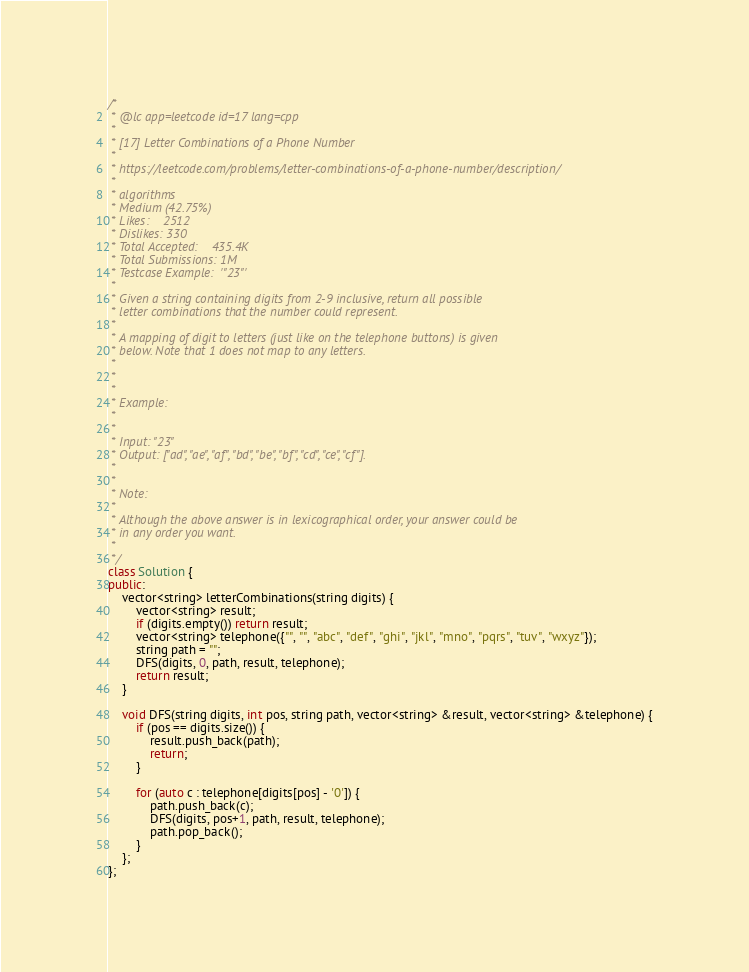<code> <loc_0><loc_0><loc_500><loc_500><_C++_>/*
 * @lc app=leetcode id=17 lang=cpp
 *
 * [17] Letter Combinations of a Phone Number
 *
 * https://leetcode.com/problems/letter-combinations-of-a-phone-number/description/
 *
 * algorithms
 * Medium (42.75%)
 * Likes:    2512
 * Dislikes: 330
 * Total Accepted:    435.4K
 * Total Submissions: 1M
 * Testcase Example:  '"23"'
 *
 * Given a string containing digits from 2-9 inclusive, return all possible
 * letter combinations that the number could represent.
 * 
 * A mapping of digit to letters (just like on the telephone buttons) is given
 * below. Note that 1 does not map to any letters.
 * 
 * 
 * 
 * Example:
 * 
 * 
 * Input: "23"
 * Output: ["ad", "ae", "af", "bd", "be", "bf", "cd", "ce", "cf"].
 * 
 * 
 * Note:
 * 
 * Although the above answer is in lexicographical order, your answer could be
 * in any order you want.
 * 
 */
class Solution {
public:
    vector<string> letterCombinations(string digits) {
        vector<string> result;
        if (digits.empty()) return result;
        vector<string> telephone({"", "", "abc", "def", "ghi", "jkl", "mno", "pqrs", "tuv", "wxyz"});
        string path = "";
        DFS(digits, 0, path, result, telephone);
        return result;
    }

    void DFS(string digits, int pos, string path, vector<string> &result, vector<string> &telephone) {
        if (pos == digits.size()) {
            result.push_back(path);
            return;
        }

        for (auto c : telephone[digits[pos] - '0']) {
            path.push_back(c);
            DFS(digits, pos+1, path, result, telephone);
            path.pop_back();
        }
    };
};

</code> 